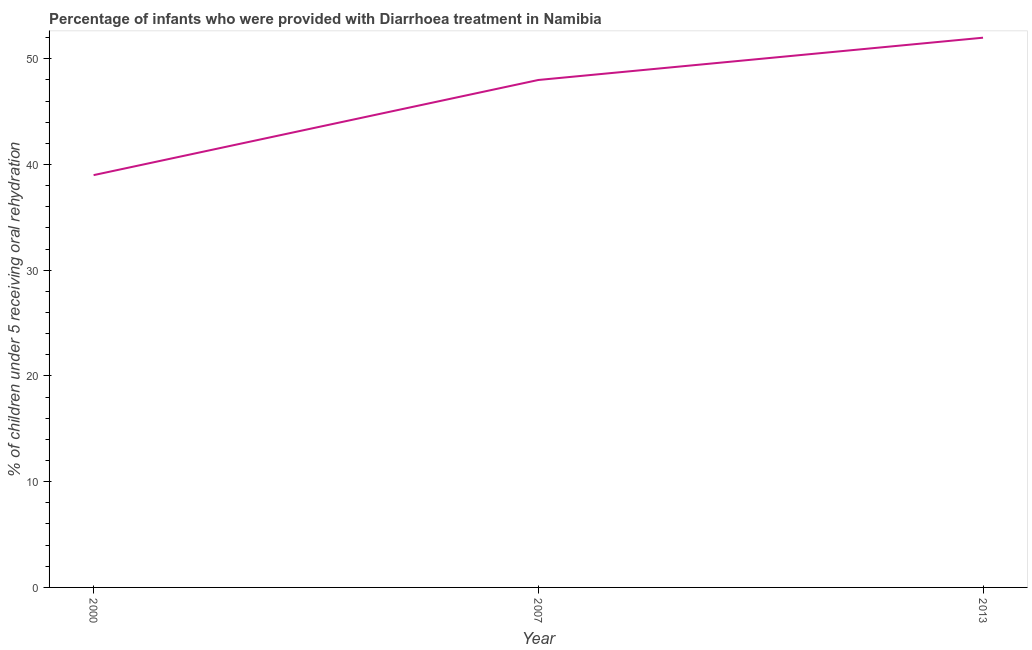What is the percentage of children who were provided with treatment diarrhoea in 2007?
Offer a very short reply. 48. Across all years, what is the maximum percentage of children who were provided with treatment diarrhoea?
Ensure brevity in your answer.  52. Across all years, what is the minimum percentage of children who were provided with treatment diarrhoea?
Your answer should be very brief. 39. In which year was the percentage of children who were provided with treatment diarrhoea minimum?
Give a very brief answer. 2000. What is the sum of the percentage of children who were provided with treatment diarrhoea?
Make the answer very short. 139. What is the difference between the percentage of children who were provided with treatment diarrhoea in 2007 and 2013?
Provide a succinct answer. -4. What is the average percentage of children who were provided with treatment diarrhoea per year?
Ensure brevity in your answer.  46.33. What is the median percentage of children who were provided with treatment diarrhoea?
Keep it short and to the point. 48. In how many years, is the percentage of children who were provided with treatment diarrhoea greater than 30 %?
Give a very brief answer. 3. Do a majority of the years between 2013 and 2007 (inclusive) have percentage of children who were provided with treatment diarrhoea greater than 28 %?
Provide a succinct answer. No. What is the ratio of the percentage of children who were provided with treatment diarrhoea in 2007 to that in 2013?
Make the answer very short. 0.92. Is the difference between the percentage of children who were provided with treatment diarrhoea in 2000 and 2013 greater than the difference between any two years?
Provide a short and direct response. Yes. What is the difference between the highest and the lowest percentage of children who were provided with treatment diarrhoea?
Offer a very short reply. 13. How many years are there in the graph?
Offer a very short reply. 3. What is the difference between two consecutive major ticks on the Y-axis?
Ensure brevity in your answer.  10. Does the graph contain grids?
Make the answer very short. No. What is the title of the graph?
Provide a short and direct response. Percentage of infants who were provided with Diarrhoea treatment in Namibia. What is the label or title of the Y-axis?
Offer a terse response. % of children under 5 receiving oral rehydration. What is the % of children under 5 receiving oral rehydration of 2007?
Give a very brief answer. 48. What is the % of children under 5 receiving oral rehydration in 2013?
Give a very brief answer. 52. What is the difference between the % of children under 5 receiving oral rehydration in 2000 and 2007?
Offer a very short reply. -9. What is the difference between the % of children under 5 receiving oral rehydration in 2007 and 2013?
Offer a terse response. -4. What is the ratio of the % of children under 5 receiving oral rehydration in 2000 to that in 2007?
Provide a short and direct response. 0.81. What is the ratio of the % of children under 5 receiving oral rehydration in 2007 to that in 2013?
Offer a very short reply. 0.92. 